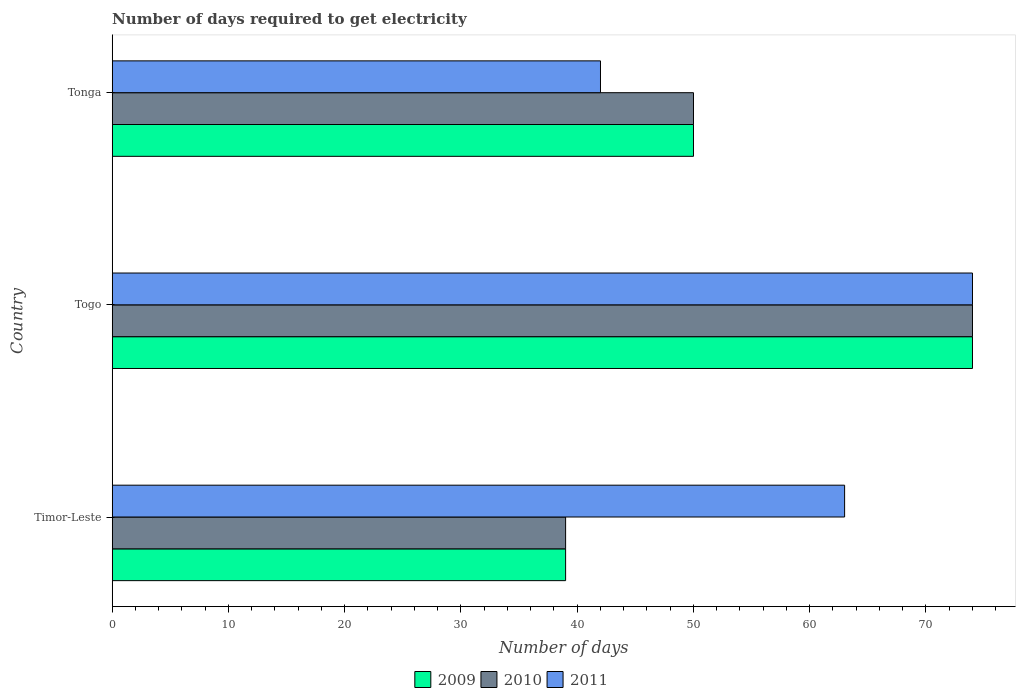How many bars are there on the 2nd tick from the top?
Your response must be concise. 3. How many bars are there on the 3rd tick from the bottom?
Provide a succinct answer. 3. What is the label of the 3rd group of bars from the top?
Your response must be concise. Timor-Leste. Across all countries, what is the maximum number of days required to get electricity in in 2010?
Provide a succinct answer. 74. In which country was the number of days required to get electricity in in 2009 maximum?
Your answer should be compact. Togo. In which country was the number of days required to get electricity in in 2010 minimum?
Give a very brief answer. Timor-Leste. What is the total number of days required to get electricity in in 2010 in the graph?
Provide a succinct answer. 163. What is the difference between the number of days required to get electricity in in 2011 in Timor-Leste and that in Togo?
Give a very brief answer. -11. What is the difference between the number of days required to get electricity in in 2010 in Togo and the number of days required to get electricity in in 2009 in Timor-Leste?
Your response must be concise. 35. What is the average number of days required to get electricity in in 2010 per country?
Ensure brevity in your answer.  54.33. In how many countries, is the number of days required to get electricity in in 2009 greater than 36 days?
Give a very brief answer. 3. What is the ratio of the number of days required to get electricity in in 2011 in Togo to that in Tonga?
Keep it short and to the point. 1.76. Is the difference between the number of days required to get electricity in in 2010 in Togo and Tonga greater than the difference between the number of days required to get electricity in in 2011 in Togo and Tonga?
Provide a succinct answer. No. What is the difference between the highest and the second highest number of days required to get electricity in in 2010?
Your answer should be very brief. 24. What does the 2nd bar from the bottom in Timor-Leste represents?
Make the answer very short. 2010. What is the difference between two consecutive major ticks on the X-axis?
Keep it short and to the point. 10. Does the graph contain any zero values?
Your answer should be very brief. No. Does the graph contain grids?
Keep it short and to the point. No. Where does the legend appear in the graph?
Keep it short and to the point. Bottom center. What is the title of the graph?
Keep it short and to the point. Number of days required to get electricity. What is the label or title of the X-axis?
Make the answer very short. Number of days. What is the Number of days of 2011 in Timor-Leste?
Offer a very short reply. 63. What is the Number of days of 2010 in Togo?
Make the answer very short. 74. What is the Number of days of 2009 in Tonga?
Your answer should be compact. 50. What is the Number of days of 2010 in Tonga?
Your response must be concise. 50. What is the Number of days in 2011 in Tonga?
Provide a succinct answer. 42. Across all countries, what is the maximum Number of days of 2010?
Your response must be concise. 74. Across all countries, what is the maximum Number of days in 2011?
Make the answer very short. 74. Across all countries, what is the minimum Number of days in 2010?
Your response must be concise. 39. Across all countries, what is the minimum Number of days in 2011?
Keep it short and to the point. 42. What is the total Number of days in 2009 in the graph?
Your answer should be compact. 163. What is the total Number of days of 2010 in the graph?
Make the answer very short. 163. What is the total Number of days in 2011 in the graph?
Keep it short and to the point. 179. What is the difference between the Number of days in 2009 in Timor-Leste and that in Togo?
Give a very brief answer. -35. What is the difference between the Number of days in 2010 in Timor-Leste and that in Togo?
Give a very brief answer. -35. What is the difference between the Number of days of 2009 in Timor-Leste and that in Tonga?
Offer a terse response. -11. What is the difference between the Number of days of 2010 in Timor-Leste and that in Tonga?
Your answer should be very brief. -11. What is the difference between the Number of days in 2011 in Timor-Leste and that in Tonga?
Provide a succinct answer. 21. What is the difference between the Number of days in 2009 in Togo and that in Tonga?
Your answer should be compact. 24. What is the difference between the Number of days of 2011 in Togo and that in Tonga?
Make the answer very short. 32. What is the difference between the Number of days in 2009 in Timor-Leste and the Number of days in 2010 in Togo?
Provide a succinct answer. -35. What is the difference between the Number of days of 2009 in Timor-Leste and the Number of days of 2011 in Togo?
Keep it short and to the point. -35. What is the difference between the Number of days in 2010 in Timor-Leste and the Number of days in 2011 in Togo?
Offer a terse response. -35. What is the difference between the Number of days in 2010 in Timor-Leste and the Number of days in 2011 in Tonga?
Provide a short and direct response. -3. What is the difference between the Number of days in 2009 in Togo and the Number of days in 2010 in Tonga?
Provide a short and direct response. 24. What is the difference between the Number of days in 2010 in Togo and the Number of days in 2011 in Tonga?
Provide a short and direct response. 32. What is the average Number of days in 2009 per country?
Provide a succinct answer. 54.33. What is the average Number of days in 2010 per country?
Provide a short and direct response. 54.33. What is the average Number of days in 2011 per country?
Offer a terse response. 59.67. What is the difference between the Number of days in 2009 and Number of days in 2010 in Timor-Leste?
Ensure brevity in your answer.  0. What is the difference between the Number of days of 2009 and Number of days of 2011 in Timor-Leste?
Provide a succinct answer. -24. What is the difference between the Number of days in 2010 and Number of days in 2011 in Timor-Leste?
Your response must be concise. -24. What is the difference between the Number of days of 2009 and Number of days of 2010 in Togo?
Keep it short and to the point. 0. What is the difference between the Number of days in 2010 and Number of days in 2011 in Togo?
Your answer should be compact. 0. What is the difference between the Number of days in 2010 and Number of days in 2011 in Tonga?
Ensure brevity in your answer.  8. What is the ratio of the Number of days of 2009 in Timor-Leste to that in Togo?
Your answer should be compact. 0.53. What is the ratio of the Number of days of 2010 in Timor-Leste to that in Togo?
Make the answer very short. 0.53. What is the ratio of the Number of days in 2011 in Timor-Leste to that in Togo?
Keep it short and to the point. 0.85. What is the ratio of the Number of days of 2009 in Timor-Leste to that in Tonga?
Give a very brief answer. 0.78. What is the ratio of the Number of days in 2010 in Timor-Leste to that in Tonga?
Your response must be concise. 0.78. What is the ratio of the Number of days of 2011 in Timor-Leste to that in Tonga?
Keep it short and to the point. 1.5. What is the ratio of the Number of days of 2009 in Togo to that in Tonga?
Provide a short and direct response. 1.48. What is the ratio of the Number of days in 2010 in Togo to that in Tonga?
Keep it short and to the point. 1.48. What is the ratio of the Number of days in 2011 in Togo to that in Tonga?
Ensure brevity in your answer.  1.76. What is the difference between the highest and the second highest Number of days of 2010?
Your answer should be very brief. 24. What is the difference between the highest and the second highest Number of days of 2011?
Make the answer very short. 11. 